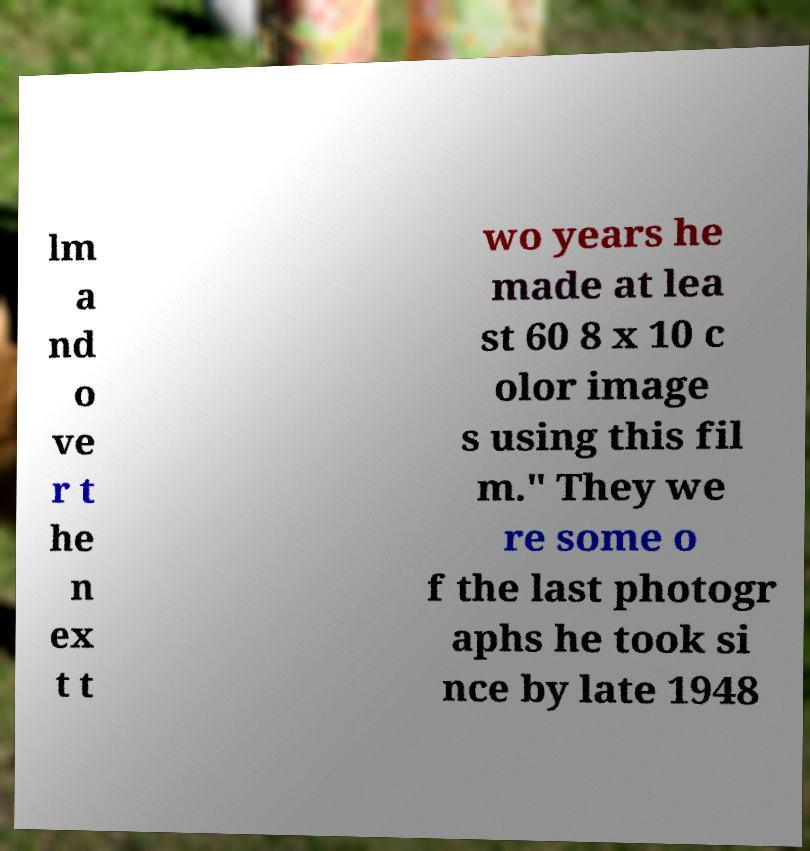Can you accurately transcribe the text from the provided image for me? lm a nd o ve r t he n ex t t wo years he made at lea st 60 8 x 10 c olor image s using this fil m." They we re some o f the last photogr aphs he took si nce by late 1948 